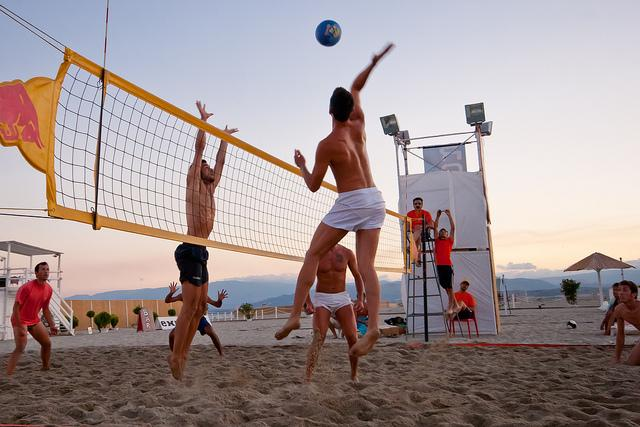What type volleyball is being played here? beach 